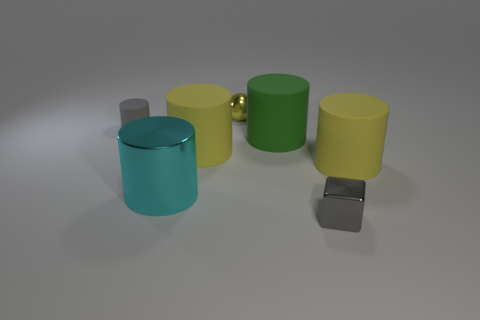Are there more big cyan cylinders on the right side of the tiny metallic ball than large cyan things that are behind the cyan cylinder?
Offer a very short reply. No. What shape is the small thing that is the same color as the tiny matte cylinder?
Your answer should be very brief. Cube. What shape is the matte thing that is the same size as the gray shiny block?
Your response must be concise. Cylinder. What number of other things are there of the same material as the tiny gray cylinder
Ensure brevity in your answer.  3. Is the number of large yellow cylinders that are on the right side of the large cyan metal cylinder greater than the number of small gray cubes?
Your answer should be compact. Yes. Are there any cyan metal things on the right side of the metal cylinder?
Provide a succinct answer. No. Do the yellow ball and the cyan cylinder have the same size?
Your answer should be compact. No. There is a gray matte thing that is the same shape as the green thing; what is its size?
Give a very brief answer. Small. There is a ball that is on the left side of the gray metal object on the right side of the large cyan metal cylinder; what is it made of?
Your answer should be compact. Metal. Does the large cyan thing have the same shape as the small gray matte object?
Give a very brief answer. Yes. 